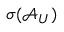<formula> <loc_0><loc_0><loc_500><loc_500>\sigma ( \mathcal { A } _ { U } )</formula> 